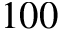Convert formula to latex. <formula><loc_0><loc_0><loc_500><loc_500>1 0 0</formula> 